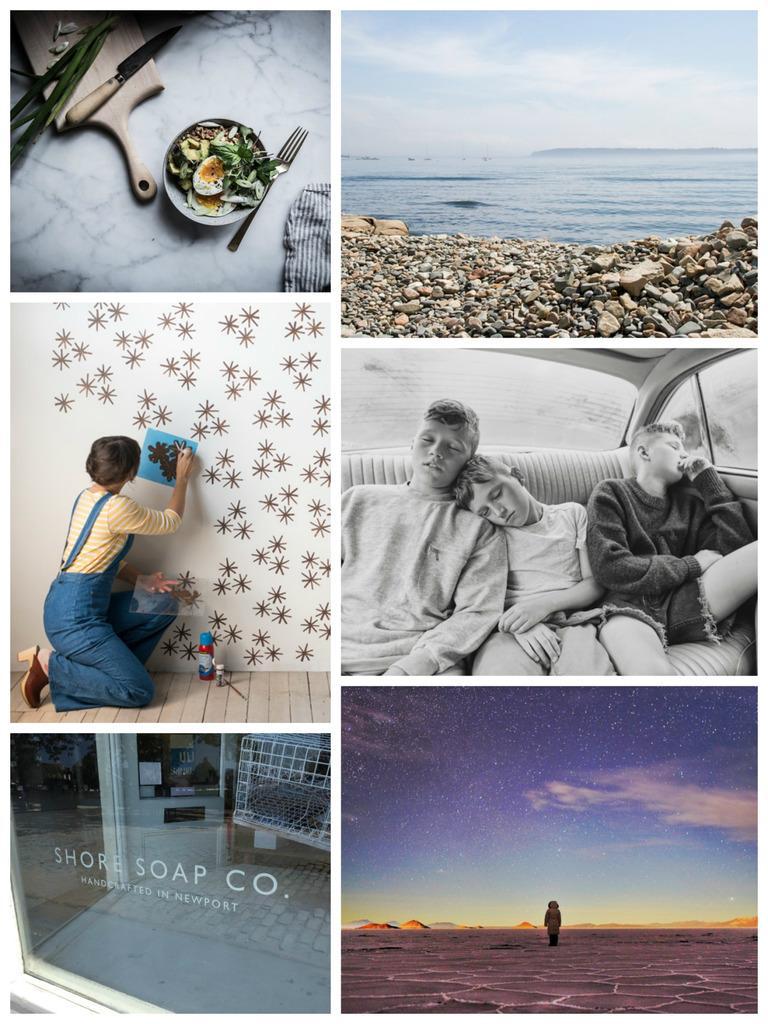Can you describe this image briefly? This is a collage picture. Here we can see a plate, fork, food, knife, water, stones, and sky. There are three persons inside a vehicle and there is a woman. Here we can see a wall and a bottle. 